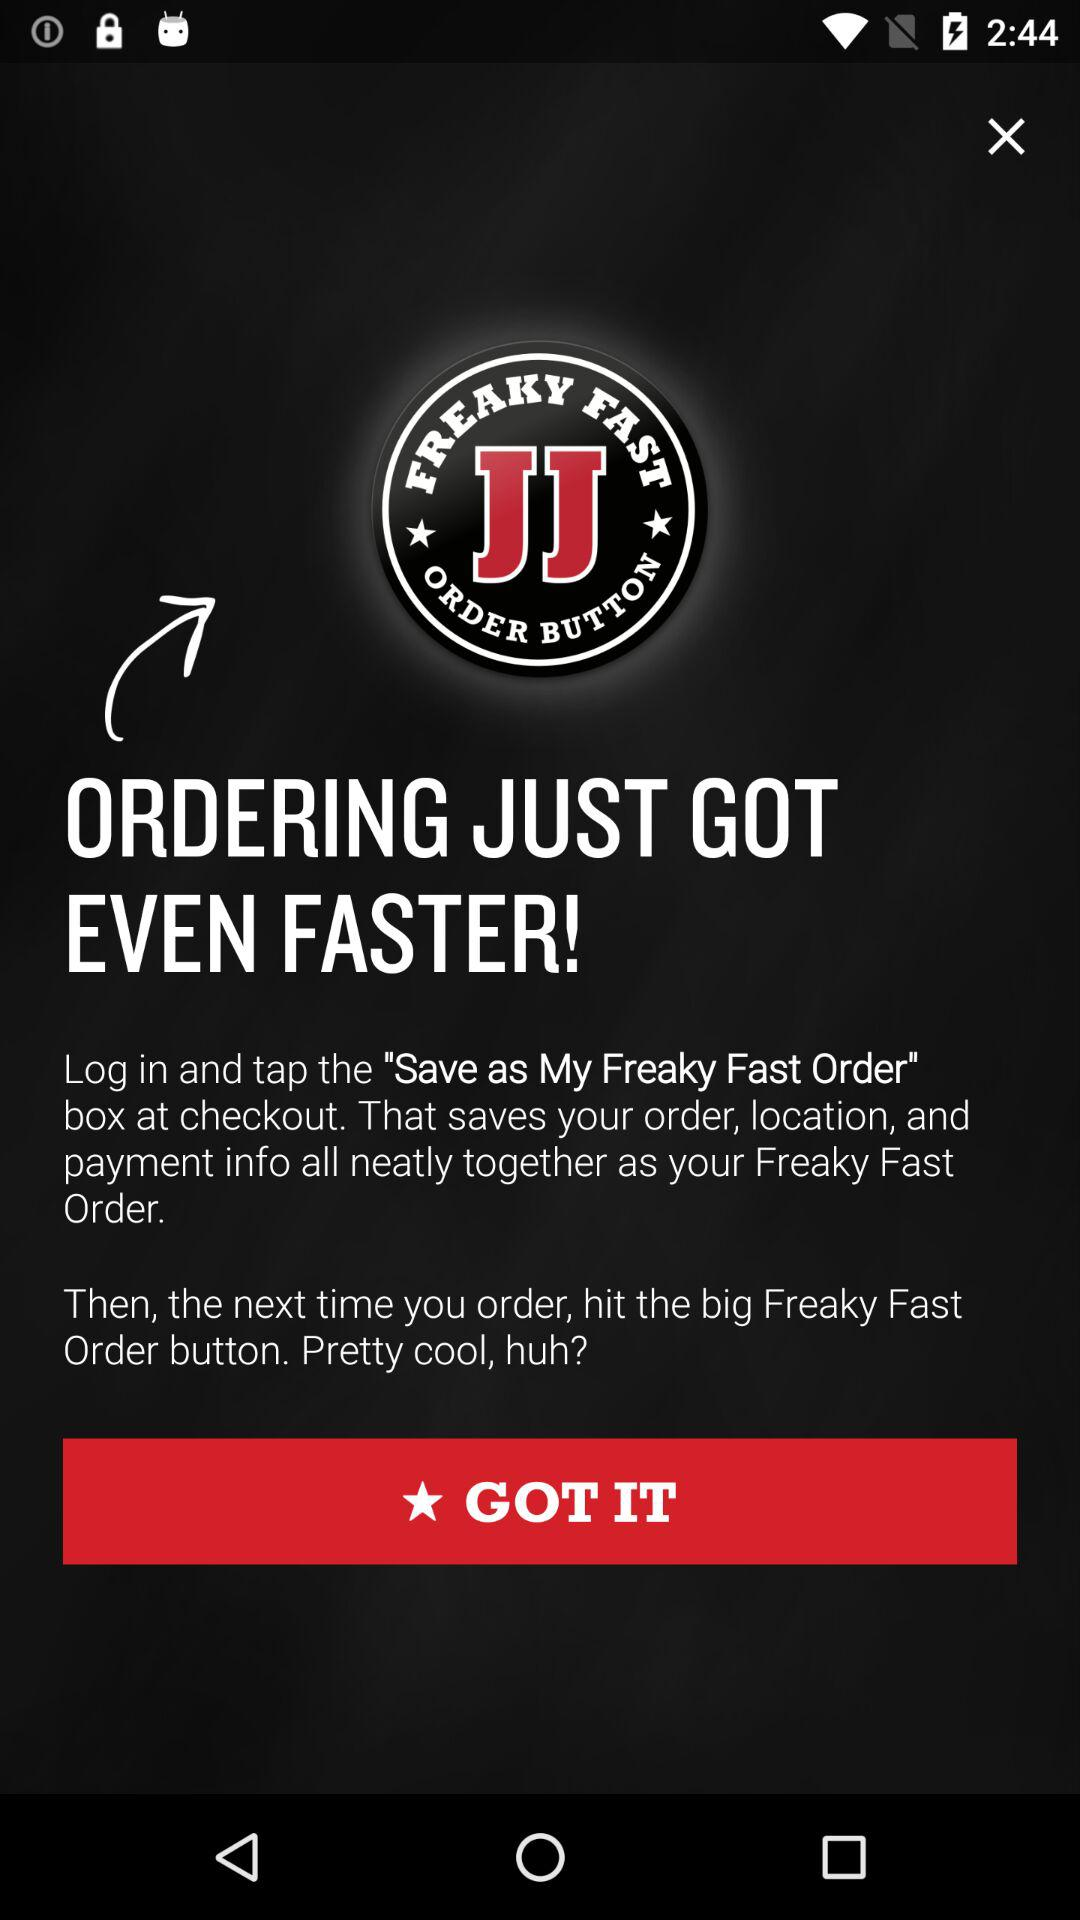How fast is a "Freaky Fast" order?
When the provided information is insufficient, respond with <no answer>. <no answer> 